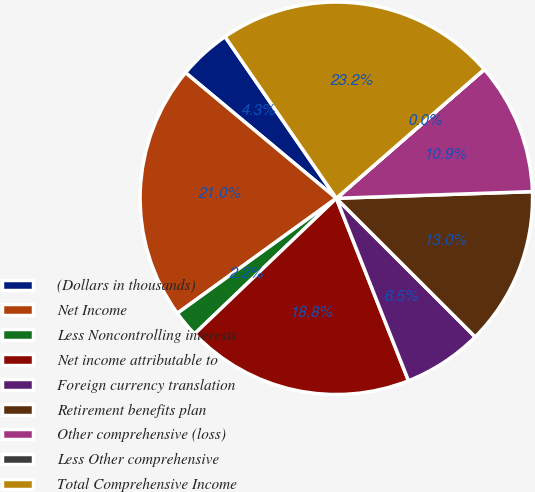Convert chart. <chart><loc_0><loc_0><loc_500><loc_500><pie_chart><fcel>(Dollars in thousands)<fcel>Net Income<fcel>Less Noncontrolling interests<fcel>Net income attributable to<fcel>Foreign currency translation<fcel>Retirement benefits plan<fcel>Other comprehensive (loss)<fcel>Less Other comprehensive<fcel>Total Comprehensive Income<nl><fcel>4.35%<fcel>21.02%<fcel>2.18%<fcel>18.85%<fcel>6.52%<fcel>13.03%<fcel>10.86%<fcel>0.01%<fcel>23.19%<nl></chart> 